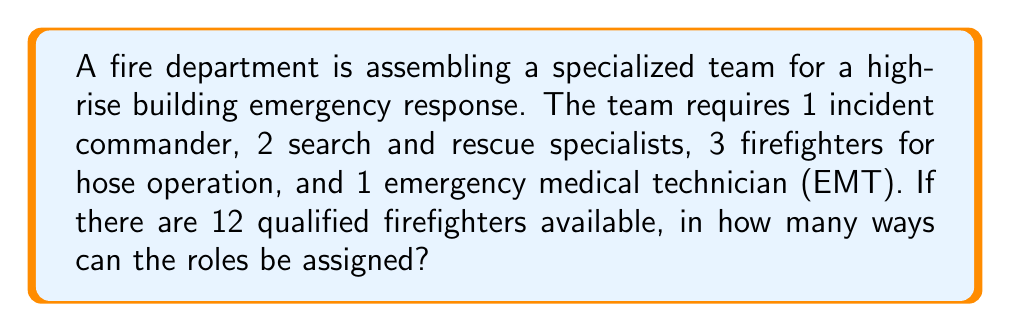Solve this math problem. Let's approach this step-by-step using the multiplication principle of counting:

1) First, we need to choose 1 incident commander from 12 firefighters:
   $${12 \choose 1} = 12$$ ways

2) After selecting the incident commander, we have 11 firefighters left. We need to choose 2 search and rescue specialists:
   $${11 \choose 2} = 55$$ ways

3) Now we have 9 firefighters left, from which we need to select 3 for hose operation:
   $${9 \choose 3} = 84$$ ways

4) Finally, we need to choose 1 EMT from the remaining 6 firefighters:
   $${6 \choose 1} = 6$$ ways

5) By the multiplication principle, the total number of ways to assign the roles is:

   $$12 \times 55 \times 84 \times 6 = 332,640$$

This problem is an application of permutations without repetition, where the order of selection matters (as each role is distinct) and each firefighter can only be assigned to one role.
Answer: 332,640 ways 